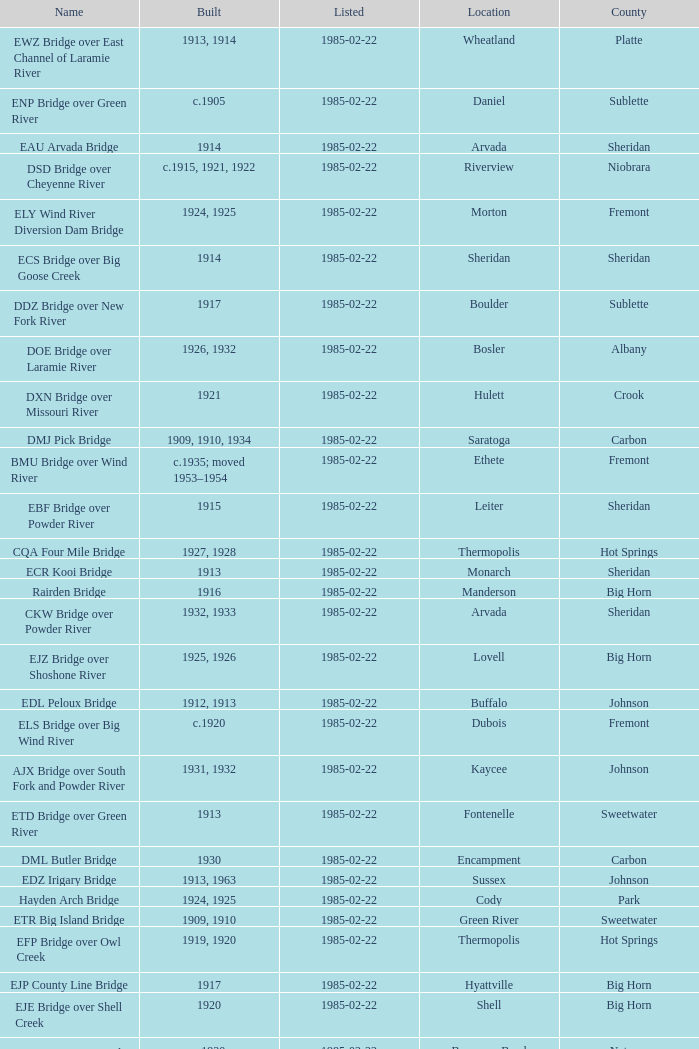In what year was the bridge in Lovell built? 1925, 1926. Help me parse the entirety of this table. {'header': ['Name', 'Built', 'Listed', 'Location', 'County'], 'rows': [['EWZ Bridge over East Channel of Laramie River', '1913, 1914', '1985-02-22', 'Wheatland', 'Platte'], ['ENP Bridge over Green River', 'c.1905', '1985-02-22', 'Daniel', 'Sublette'], ['EAU Arvada Bridge', '1914', '1985-02-22', 'Arvada', 'Sheridan'], ['DSD Bridge over Cheyenne River', 'c.1915, 1921, 1922', '1985-02-22', 'Riverview', 'Niobrara'], ['ELY Wind River Diversion Dam Bridge', '1924, 1925', '1985-02-22', 'Morton', 'Fremont'], ['ECS Bridge over Big Goose Creek', '1914', '1985-02-22', 'Sheridan', 'Sheridan'], ['DDZ Bridge over New Fork River', '1917', '1985-02-22', 'Boulder', 'Sublette'], ['DOE Bridge over Laramie River', '1926, 1932', '1985-02-22', 'Bosler', 'Albany'], ['DXN Bridge over Missouri River', '1921', '1985-02-22', 'Hulett', 'Crook'], ['DMJ Pick Bridge', '1909, 1910, 1934', '1985-02-22', 'Saratoga', 'Carbon'], ['BMU Bridge over Wind River', 'c.1935; moved 1953–1954', '1985-02-22', 'Ethete', 'Fremont'], ['EBF Bridge over Powder River', '1915', '1985-02-22', 'Leiter', 'Sheridan'], ['CQA Four Mile Bridge', '1927, 1928', '1985-02-22', 'Thermopolis', 'Hot Springs'], ['ECR Kooi Bridge', '1913', '1985-02-22', 'Monarch', 'Sheridan'], ['Rairden Bridge', '1916', '1985-02-22', 'Manderson', 'Big Horn'], ['CKW Bridge over Powder River', '1932, 1933', '1985-02-22', 'Arvada', 'Sheridan'], ['EJZ Bridge over Shoshone River', '1925, 1926', '1985-02-22', 'Lovell', 'Big Horn'], ['EDL Peloux Bridge', '1912, 1913', '1985-02-22', 'Buffalo', 'Johnson'], ['ELS Bridge over Big Wind River', 'c.1920', '1985-02-22', 'Dubois', 'Fremont'], ['AJX Bridge over South Fork and Powder River', '1931, 1932', '1985-02-22', 'Kaycee', 'Johnson'], ['ETD Bridge over Green River', '1913', '1985-02-22', 'Fontenelle', 'Sweetwater'], ['DML Butler Bridge', '1930', '1985-02-22', 'Encampment', 'Carbon'], ['EDZ Irigary Bridge', '1913, 1963', '1985-02-22', 'Sussex', 'Johnson'], ['Hayden Arch Bridge', '1924, 1925', '1985-02-22', 'Cody', 'Park'], ['ETR Big Island Bridge', '1909, 1910', '1985-02-22', 'Green River', 'Sweetwater'], ['EFP Bridge over Owl Creek', '1919, 1920', '1985-02-22', 'Thermopolis', 'Hot Springs'], ['EJP County Line Bridge', '1917', '1985-02-22', 'Hyattville', 'Big Horn'], ['EJE Bridge over Shell Creek', '1920', '1985-02-22', 'Shell', 'Big Horn'], ['DUX Bessemer Bend Bridge', 'c.1920', '1985-02-22', 'Bessemer Bend', 'Natrona'], ["ERT Bridge over Black's Fork", 'c.1920', '1985-02-22', 'Fort Bridger', 'Uinta'], ['DFU Elk Mountain Bridge', '1923, 1924', '1985-02-22', 'Elk Mountain', 'Carbon']]} 